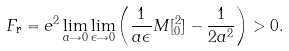Convert formula to latex. <formula><loc_0><loc_0><loc_500><loc_500>F _ { \text {r} } = e ^ { 2 } \lim _ { a \rightarrow 0 } \lim _ { \epsilon \rightarrow 0 } \left ( \frac { 1 } { a \epsilon } M [ ^ { 2 } _ { 0 } ] - \frac { 1 } { 2 a ^ { 2 } } \right ) > 0 .</formula> 